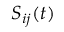Convert formula to latex. <formula><loc_0><loc_0><loc_500><loc_500>S _ { i j } ( t )</formula> 